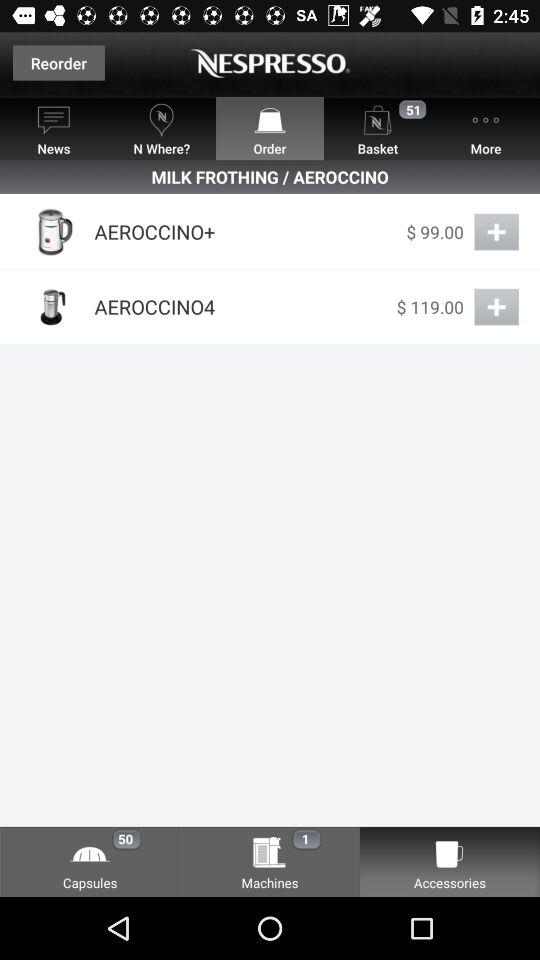What is the name of the application? The application name is "NESPRESSO". 